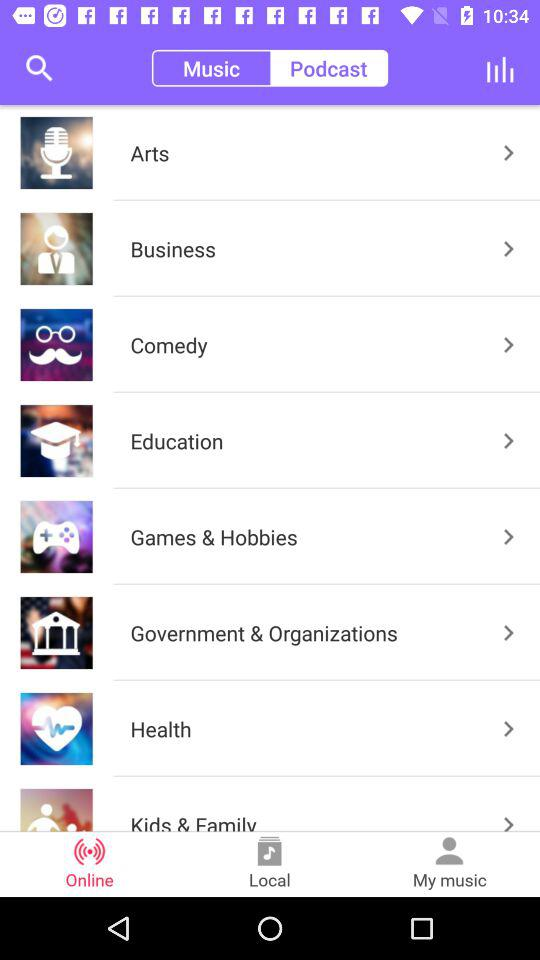What is the selected tab? The selected tabs are "Online" and "Podcast". 